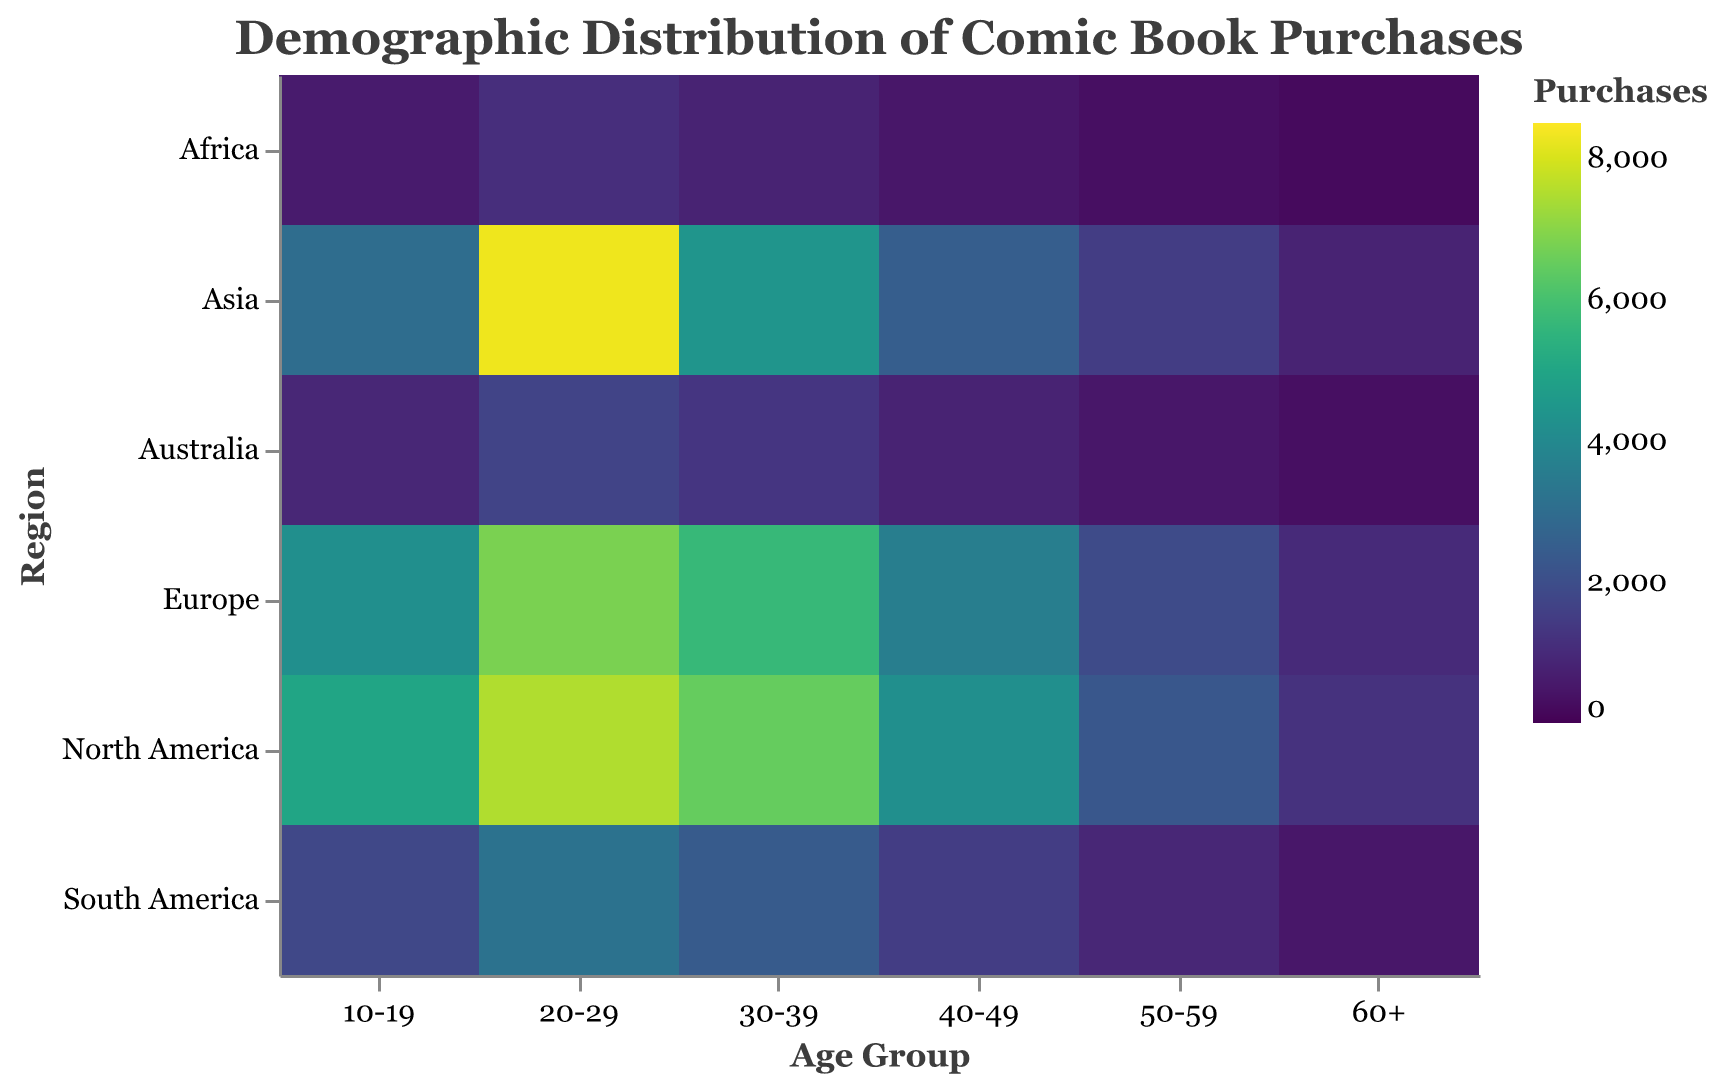What is the title of the heatmap? The title is found at the top of the heatmap. It reads "Demographic Distribution of Comic Book Purchases."
Answer: Demographic Distribution of Comic Book Purchases Which age group has the highest number of comic book purchases in Asia? By looking at the row labeled "Asia," you will see that the "20-29" age group has the highest value, with 8300 purchases.
Answer: 20-29 How many comic book purchases have been recorded in South America for the 30-39 age group? Locate the intersection of the "30-39" age group row and the "South America" column to find the value 2400.
Answer: 2400 Which region has the fewest comic book purchases in the 10-19 age group? For the "10-19" age group, the smallest value in that row is for Africa, with 600 purchases.
Answer: Africa Compare the total comic book purchases of the 20-29 and 60+ age groups in North America. Which is more, and by how much? The 20-29 age group has 7500 purchases, and the 60+ age group has 1200 purchases. The difference is 7500 - 1200 = 6300 more for the 20-29 group.
Answer: 20-29 by 6300 What is the average number of comic book purchases for the 40-49 age group across all regions? Sum of all purchases in the 40-49 age group: 4200 + 3600 + 2500 + 1500 + 800 + 500 = 13100. Dividing by the number of regions (6) gives the average as 13100 / 6 = 2183.33.
Answer: 2183.33 Which region has the largest decrease in comic book purchases between the 20-29 and 30-39 age groups? Calculate the difference between 20-29 and 30-39 for each region. North America: 7500 - 6500 = 1000, Europe: 6800 - 5700 = 1100, Asia: 8300 - 4400 = 3900, South America: 3200 - 2400 = 800, Australia: 1700 - 1300 = 400, Africa: 1100 - 800 = 300. Asia has the largest decrease of 3900.
Answer: Asia What is the total number of purchases for the "Europe" region across all age groups? Sum the values for Europe across all age groups: 4200 + 6800 + 5700 + 3600 + 1900 + 1000 = 23200.
Answer: 23200 For the "Australia" region, what is the difference in purchases between the youngest (10-19) and oldest (60+) age groups? Subtract the purchases of the 60+ age group from the 10-19 age group in Australia: 900 - 300 = 600.
Answer: 600 In which age group are comic book purchases in North America twice as high as in Europe? Divide the North American values by the European values. Only the 10-19 group achieves this: 5000 / 4200 ≈ 1.19, 7500 / 6800 ≈ 1.10, 6500 / 5700 ≈ 1.14, 4200 / 3600 ≈ 1.17, 2300 / 1900 ≈ 1.21, 1200 / 1000 ≈ 1.20. None achieve exactly twice. Answer: None.
Answer: None 